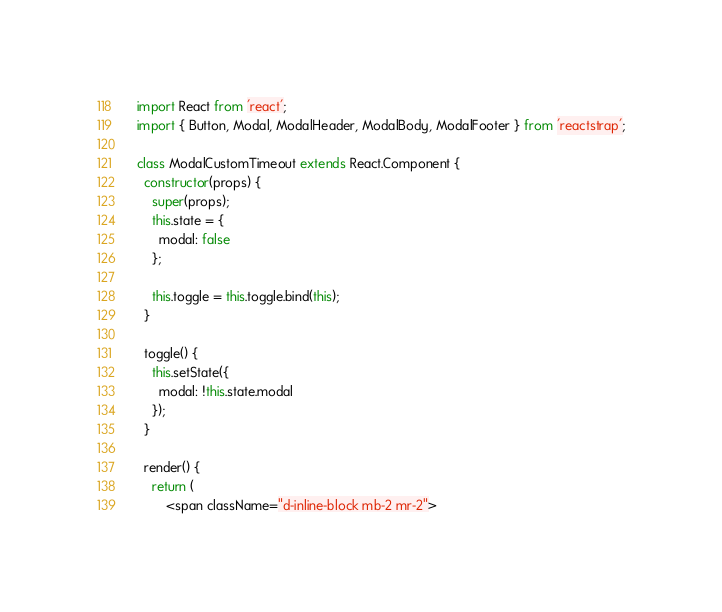<code> <loc_0><loc_0><loc_500><loc_500><_JavaScript_>import React from 'react';
import { Button, Modal, ModalHeader, ModalBody, ModalFooter } from 'reactstrap';

class ModalCustomTimeout extends React.Component {
  constructor(props) {
    super(props);
    this.state = {
      modal: false
    };

    this.toggle = this.toggle.bind(this);
  }

  toggle() {
    this.setState({
      modal: !this.state.modal
    });
  }

  render() {
    return (
        <span className="d-inline-block mb-2 mr-2"></code> 